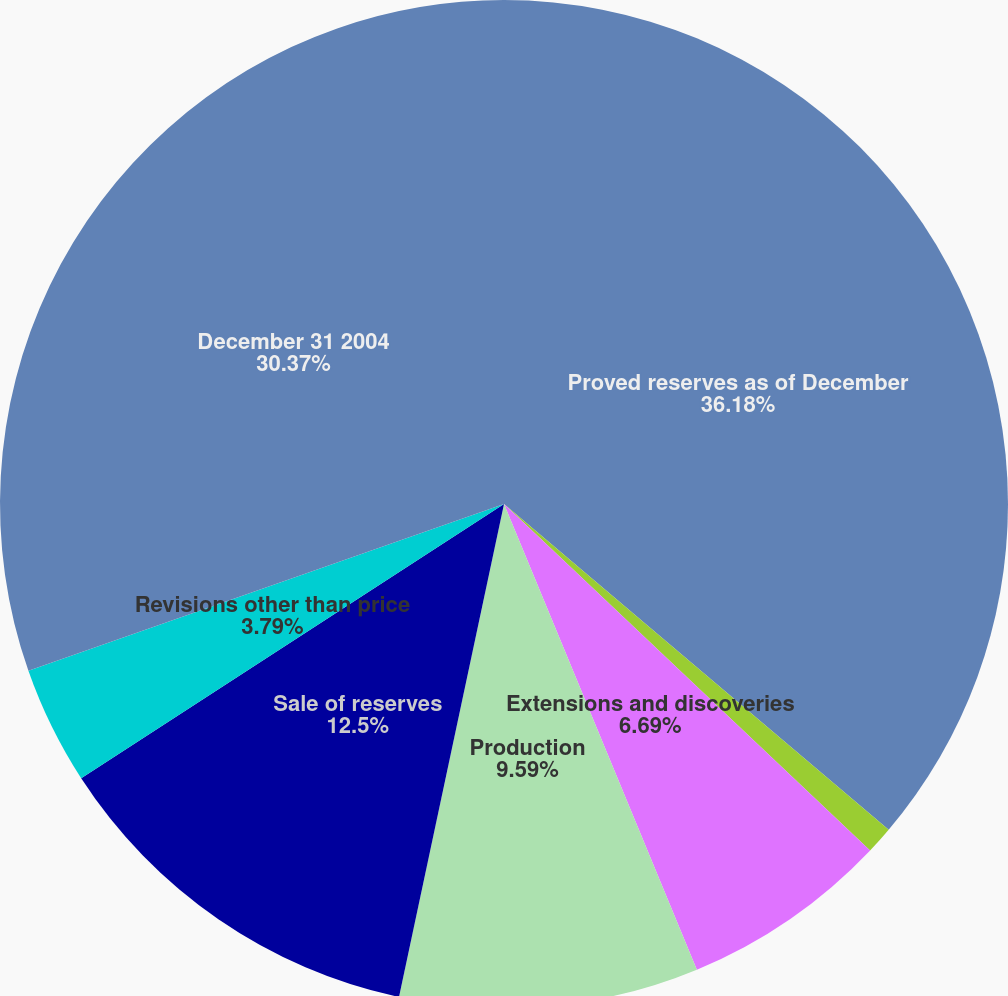Convert chart to OTSL. <chart><loc_0><loc_0><loc_500><loc_500><pie_chart><fcel>Proved reserves as of December<fcel>Revisions due to prices<fcel>Extensions and discoveries<fcel>Production<fcel>Sale of reserves<fcel>Revisions other than price<fcel>December 31 2004<nl><fcel>36.18%<fcel>0.88%<fcel>6.69%<fcel>9.59%<fcel>12.5%<fcel>3.79%<fcel>30.37%<nl></chart> 